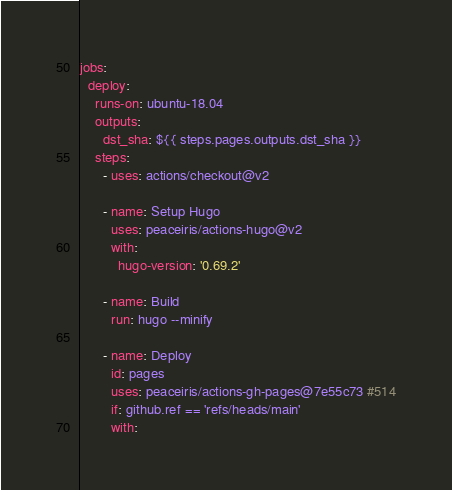Convert code to text. <code><loc_0><loc_0><loc_500><loc_500><_YAML_>jobs:
  deploy:
    runs-on: ubuntu-18.04
    outputs:
      dst_sha: ${{ steps.pages.outputs.dst_sha }}
    steps:
      - uses: actions/checkout@v2

      - name: Setup Hugo
        uses: peaceiris/actions-hugo@v2
        with:
          hugo-version: '0.69.2'

      - name: Build
        run: hugo --minify

      - name: Deploy
        id: pages
        uses: peaceiris/actions-gh-pages@7e55c73 #514
        if: github.ref == 'refs/heads/main'
        with:</code> 